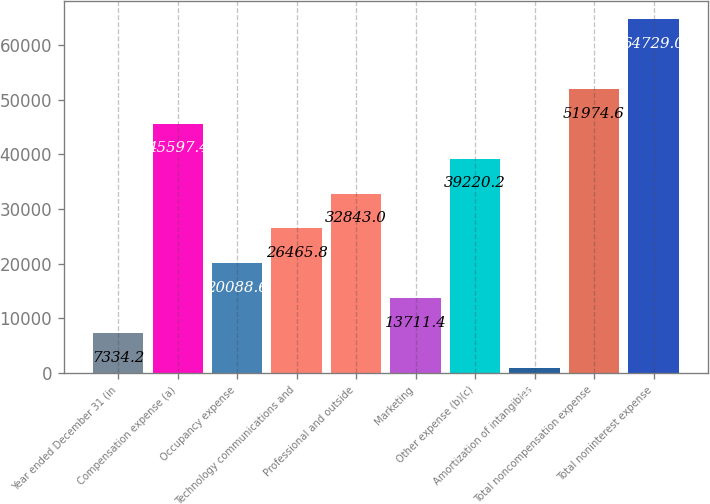Convert chart. <chart><loc_0><loc_0><loc_500><loc_500><bar_chart><fcel>Year ended December 31 (in<fcel>Compensation expense (a)<fcel>Occupancy expense<fcel>Technology communications and<fcel>Professional and outside<fcel>Marketing<fcel>Other expense (b)(c)<fcel>Amortization of intangibles<fcel>Total noncompensation expense<fcel>Total noninterest expense<nl><fcel>7334.2<fcel>45597.4<fcel>20088.6<fcel>26465.8<fcel>32843<fcel>13711.4<fcel>39220.2<fcel>957<fcel>51974.6<fcel>64729<nl></chart> 